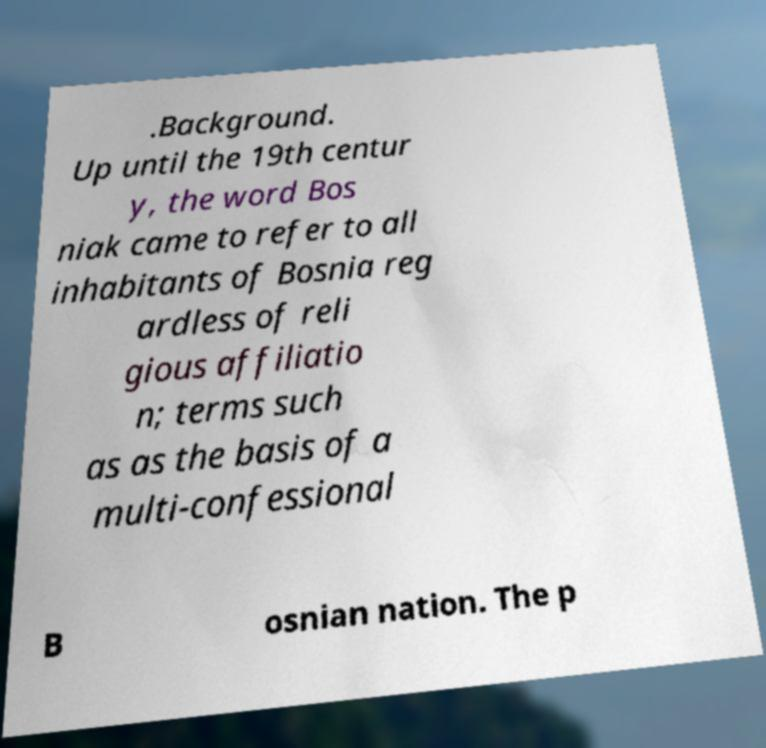Can you read and provide the text displayed in the image?This photo seems to have some interesting text. Can you extract and type it out for me? .Background. Up until the 19th centur y, the word Bos niak came to refer to all inhabitants of Bosnia reg ardless of reli gious affiliatio n; terms such as as the basis of a multi-confessional B osnian nation. The p 